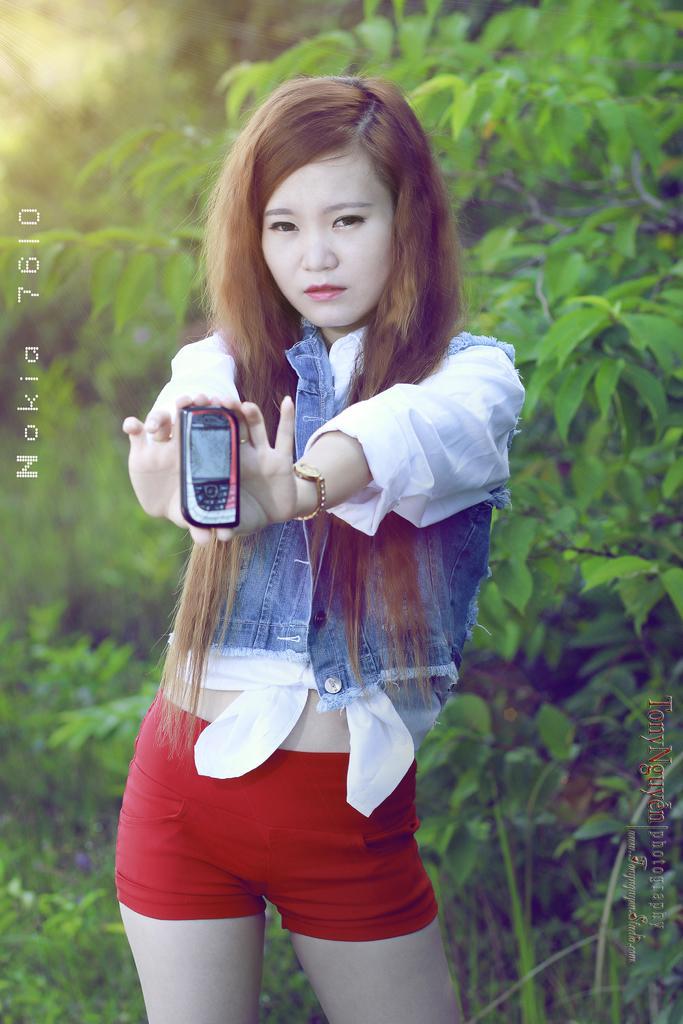Please provide a concise description of this image. Here we can see a woman is standing and holding a mobile in her hands, and at back here are the tree. 